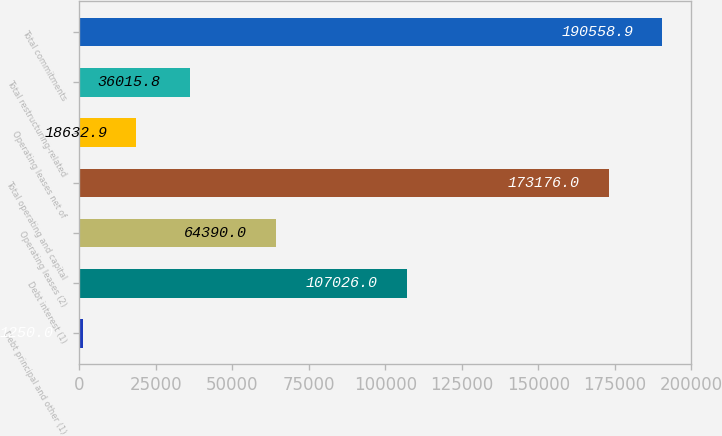Convert chart. <chart><loc_0><loc_0><loc_500><loc_500><bar_chart><fcel>Debt principal and other (1)<fcel>Debt interest (1)<fcel>Operating leases (2)<fcel>Total operating and capital<fcel>Operating leases net of<fcel>Total restructuring-related<fcel>Total commitments<nl><fcel>1250<fcel>107026<fcel>64390<fcel>173176<fcel>18632.9<fcel>36015.8<fcel>190559<nl></chart> 